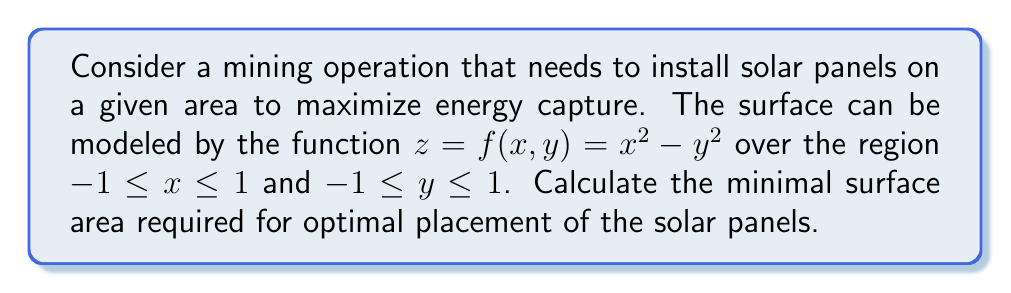Help me with this question. To find the minimal surface area, we need to use the surface area formula for a parametric surface:

1) The surface area is given by:
   $$A = \int\int_R \sqrt{1 + \left(\frac{\partial f}{\partial x}\right)^2 + \left(\frac{\partial f}{\partial y}\right)^2} \, dA$$

2) Calculate partial derivatives:
   $\frac{\partial f}{\partial x} = 2x$
   $\frac{\partial f}{\partial y} = -2y$

3) Substitute into the surface area formula:
   $$A = \int_{-1}^1 \int_{-1}^1 \sqrt{1 + (2x)^2 + (-2y)^2} \, dy \, dx$$

4) Simplify the integrand:
   $$A = \int_{-1}^1 \int_{-1}^1 \sqrt{1 + 4x^2 + 4y^2} \, dy \, dx$$

5) This integral cannot be evaluated analytically. We need to use numerical integration.

6) Using a numerical integration method (e.g., Simpson's rule or Gaussian quadrature), we can approximate the integral.

7) The result of the numerical integration gives us the minimal surface area required for optimal placement of the solar panels.

[asy]
import graph3;
import palette;

size(200,200,IgnoreAspect);
currentprojection=perspective(6,3,2);

triple f(pair t) {return (t.x,t.y,t.x^2-t.y^2);}

surface s=surface(f,(-1,-1),(1,1),8,8,Spline);

draw(s,palegreen+opacity(.7),lightgreen);
draw(zscale3D((-1,-1,1),(1,1,1)),blue);

xaxis3("$x$",Arrow3);
yaxis3("$y$",Arrow3);
zaxis3("$z$",Arrow3);
[/asy]
Answer: Approximately 5.192 square units 